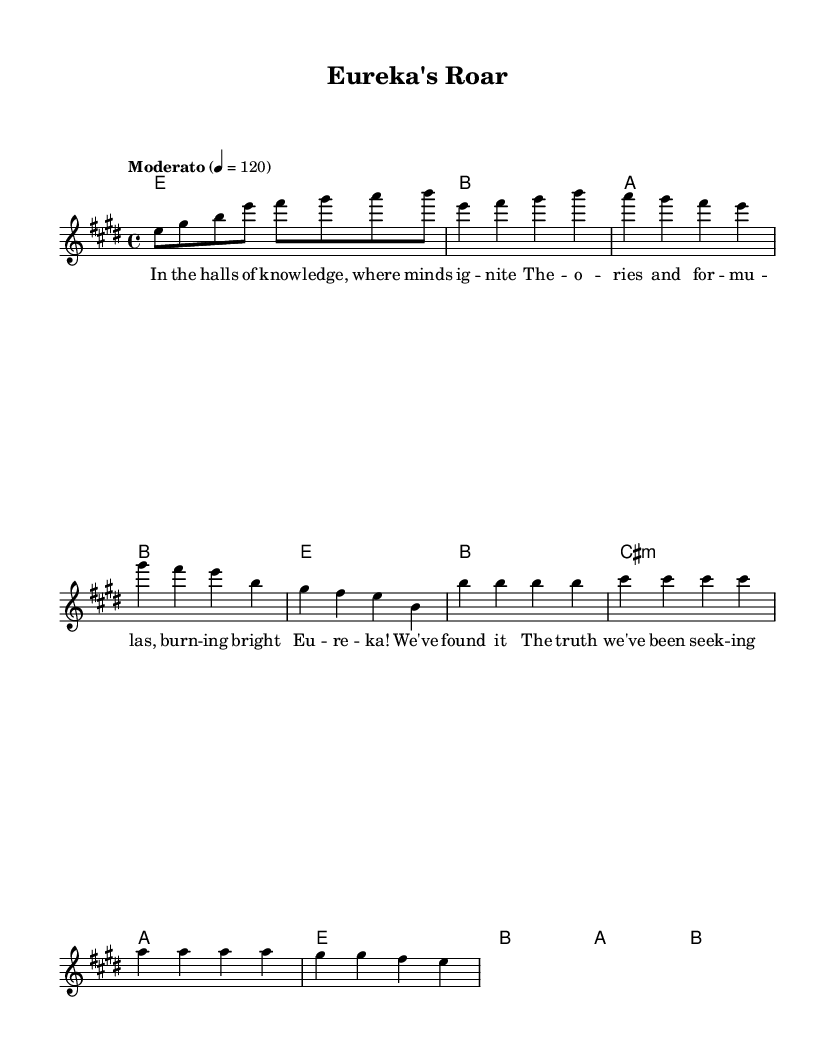What is the key signature of this music? The key signature shows two sharps, which corresponds to E major, as indicated by the notations in the global section of the code.
Answer: E major What is the time signature of this music? The time signature is specified as 4/4 in the global section, which means there are four beats per measure and the quarter note gets one beat.
Answer: 4/4 What is the tempo marking for the piece? The tempo marking in the global section directly states "Moderato" with a metronome marking of 120 beats per minute, indicating a moderate speed.
Answer: Moderato How many measures are in the verses? The verse section has 4 lines of music, with each line containing 4 measures based on the provided melody structure. Therefore, the total for the verse is 16 measures.
Answer: 16 How many distinct chords are used in the chorus? The chord mode for the chorus indicates the use of three distinct chords: E major, B major, and A major, as seen in the chord structure provided.
Answer: 3 What is the repeated word in the chorus? In examining the chorus lyrics, the word "Eureka!" appears prominently and is repeated multiple times, emphasizing the joy of discovery.
Answer: Eureka What thematic element does this piece celebrate? The lyrics and overall context of the piece celebrate intellectual pursuits and scientific discoveries, which is evident from both the title and the content of the lyrics.
Answer: Intellectual pursuits 